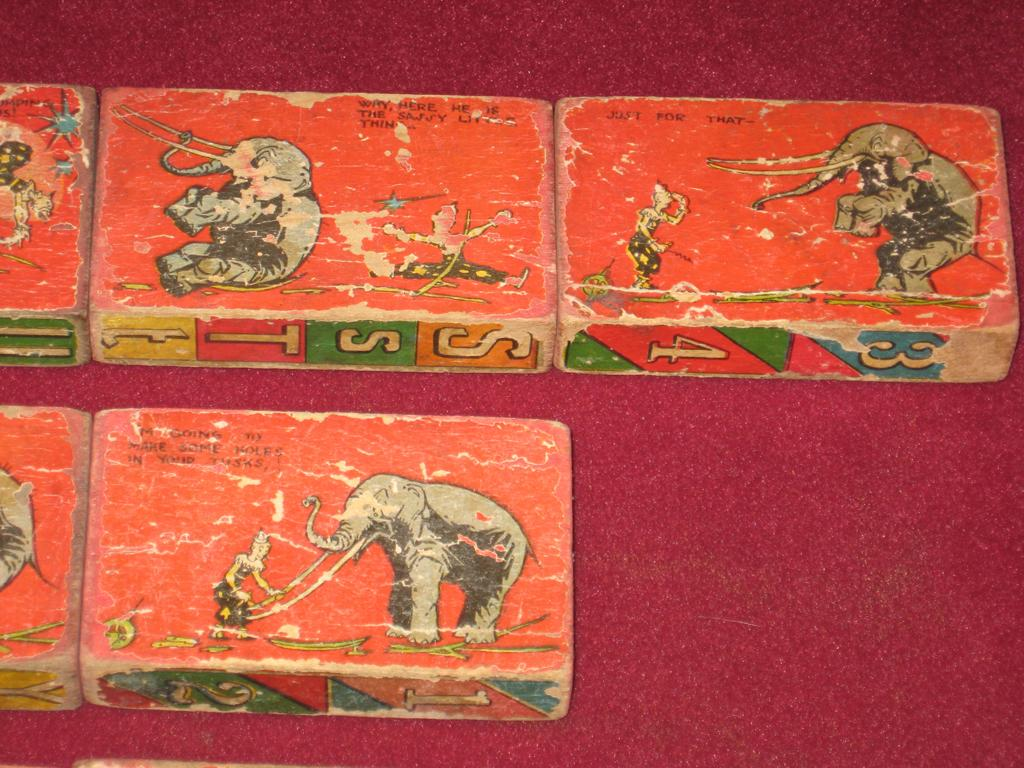What objects are present in the image? There are boxes in the image. What can be found on the boxes? There is text on the boxes. What type of surface is visible in the background of the image? There is a floor visible in the background of the image. What type of juice is being crushed on the scale in the image? There is no juice or scale present in the image; it only features boxes with text on them and a visible floor in the background. 